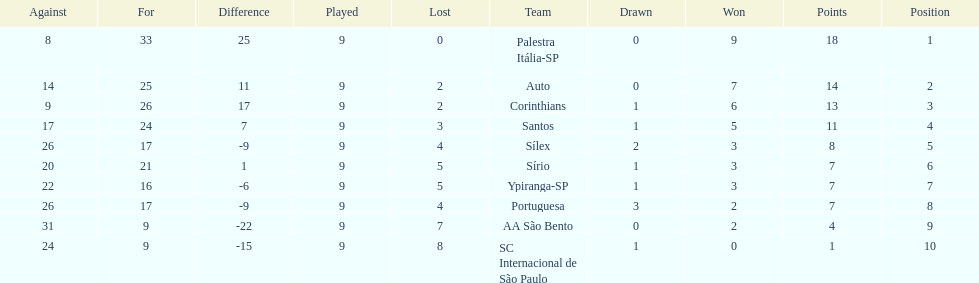In 1926 brazilian football, how many teams scored above 10 points in the season? 4. 